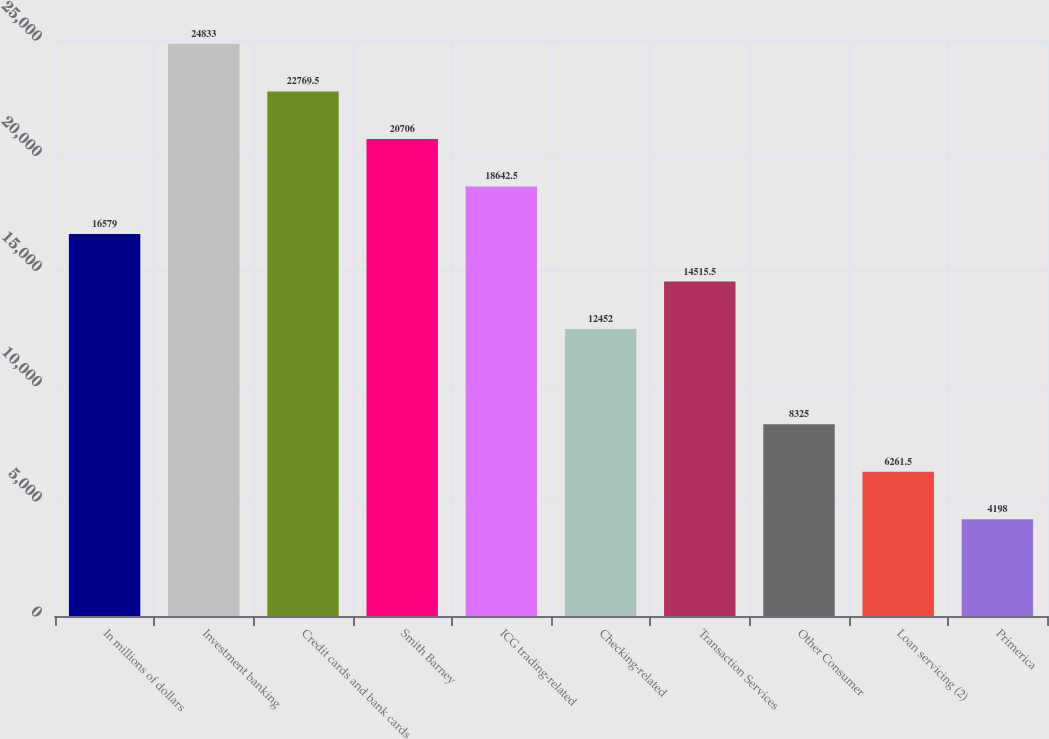Convert chart to OTSL. <chart><loc_0><loc_0><loc_500><loc_500><bar_chart><fcel>In millions of dollars<fcel>Investment banking<fcel>Credit cards and bank cards<fcel>Smith Barney<fcel>ICG trading-related<fcel>Checking-related<fcel>Transaction Services<fcel>Other Consumer<fcel>Loan servicing (2)<fcel>Primerica<nl><fcel>16579<fcel>24833<fcel>22769.5<fcel>20706<fcel>18642.5<fcel>12452<fcel>14515.5<fcel>8325<fcel>6261.5<fcel>4198<nl></chart> 